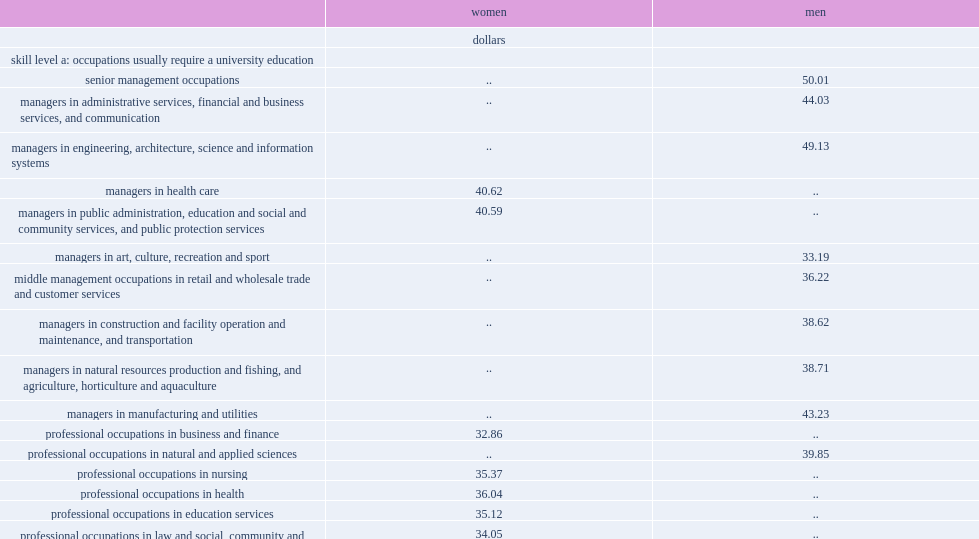What was the average hourly wage of women with professional occupations in nursing in 2015? 35.37. What was the average hourly wage of men with professional occupations in natural and applied science in 2015? 39.85. What's the difference of hourly wage between professional women working in nursing and men with professional occupations in natural and applied science in 2015? 4.48. What was the hourly wage for women in administrative occupations? 25.11. What was the hourly wage for men in construction-related trades? 29.76. 